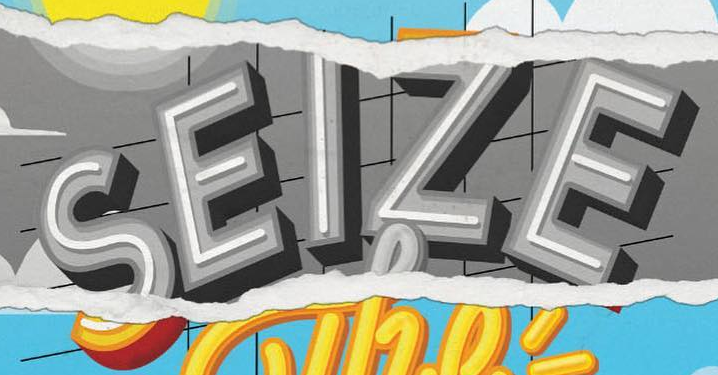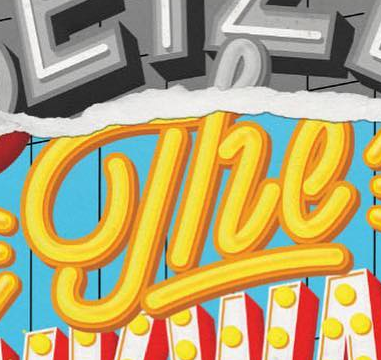What text is displayed in these images sequentially, separated by a semicolon? SEIZE; The 